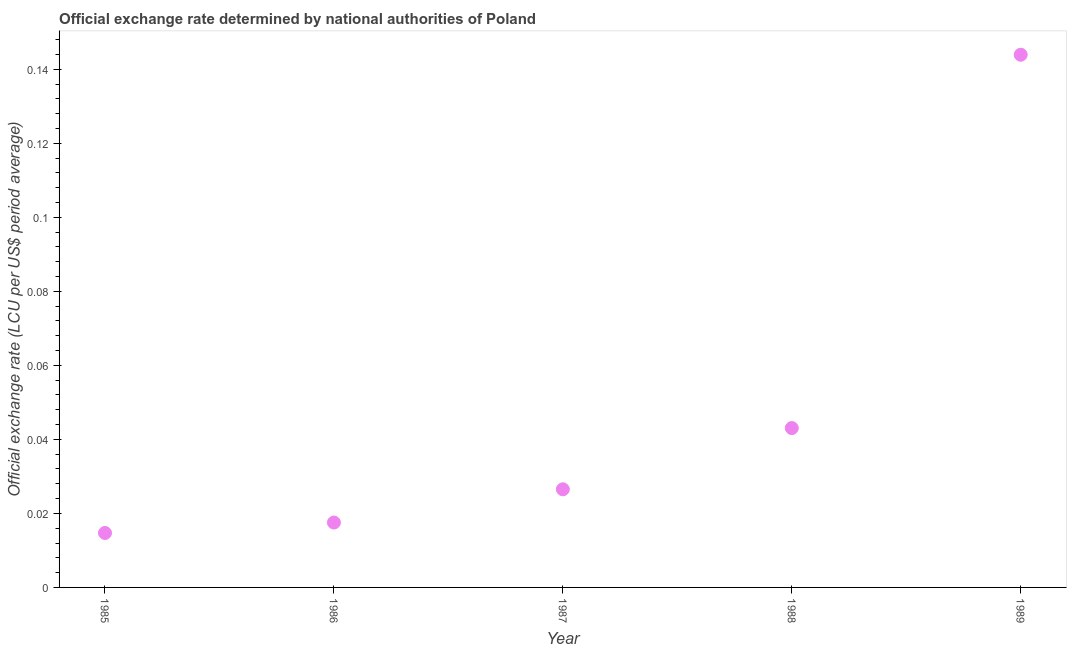What is the official exchange rate in 1985?
Ensure brevity in your answer.  0.01. Across all years, what is the maximum official exchange rate?
Provide a succinct answer. 0.14. Across all years, what is the minimum official exchange rate?
Offer a very short reply. 0.01. In which year was the official exchange rate minimum?
Your answer should be very brief. 1985. What is the sum of the official exchange rate?
Make the answer very short. 0.25. What is the difference between the official exchange rate in 1987 and 1988?
Your response must be concise. -0.02. What is the average official exchange rate per year?
Keep it short and to the point. 0.05. What is the median official exchange rate?
Your answer should be very brief. 0.03. In how many years, is the official exchange rate greater than 0.06 ?
Ensure brevity in your answer.  1. Do a majority of the years between 1986 and 1985 (inclusive) have official exchange rate greater than 0.056 ?
Offer a very short reply. No. What is the ratio of the official exchange rate in 1985 to that in 1986?
Your answer should be very brief. 0.84. Is the official exchange rate in 1987 less than that in 1989?
Make the answer very short. Yes. Is the difference between the official exchange rate in 1985 and 1987 greater than the difference between any two years?
Offer a very short reply. No. What is the difference between the highest and the second highest official exchange rate?
Give a very brief answer. 0.1. What is the difference between the highest and the lowest official exchange rate?
Your answer should be compact. 0.13. In how many years, is the official exchange rate greater than the average official exchange rate taken over all years?
Your response must be concise. 1. Does the official exchange rate monotonically increase over the years?
Ensure brevity in your answer.  Yes. How many years are there in the graph?
Keep it short and to the point. 5. What is the difference between two consecutive major ticks on the Y-axis?
Your response must be concise. 0.02. Does the graph contain grids?
Provide a short and direct response. No. What is the title of the graph?
Your answer should be very brief. Official exchange rate determined by national authorities of Poland. What is the label or title of the X-axis?
Your response must be concise. Year. What is the label or title of the Y-axis?
Offer a terse response. Official exchange rate (LCU per US$ period average). What is the Official exchange rate (LCU per US$ period average) in 1985?
Your answer should be compact. 0.01. What is the Official exchange rate (LCU per US$ period average) in 1986?
Offer a very short reply. 0.02. What is the Official exchange rate (LCU per US$ period average) in 1987?
Provide a succinct answer. 0.03. What is the Official exchange rate (LCU per US$ period average) in 1988?
Keep it short and to the point. 0.04. What is the Official exchange rate (LCU per US$ period average) in 1989?
Offer a very short reply. 0.14. What is the difference between the Official exchange rate (LCU per US$ period average) in 1985 and 1986?
Offer a very short reply. -0. What is the difference between the Official exchange rate (LCU per US$ period average) in 1985 and 1987?
Make the answer very short. -0.01. What is the difference between the Official exchange rate (LCU per US$ period average) in 1985 and 1988?
Ensure brevity in your answer.  -0.03. What is the difference between the Official exchange rate (LCU per US$ period average) in 1985 and 1989?
Provide a succinct answer. -0.13. What is the difference between the Official exchange rate (LCU per US$ period average) in 1986 and 1987?
Your answer should be compact. -0.01. What is the difference between the Official exchange rate (LCU per US$ period average) in 1986 and 1988?
Give a very brief answer. -0.03. What is the difference between the Official exchange rate (LCU per US$ period average) in 1986 and 1989?
Provide a succinct answer. -0.13. What is the difference between the Official exchange rate (LCU per US$ period average) in 1987 and 1988?
Offer a terse response. -0.02. What is the difference between the Official exchange rate (LCU per US$ period average) in 1987 and 1989?
Your answer should be compact. -0.12. What is the difference between the Official exchange rate (LCU per US$ period average) in 1988 and 1989?
Provide a short and direct response. -0.1. What is the ratio of the Official exchange rate (LCU per US$ period average) in 1985 to that in 1986?
Keep it short and to the point. 0.84. What is the ratio of the Official exchange rate (LCU per US$ period average) in 1985 to that in 1987?
Keep it short and to the point. 0.56. What is the ratio of the Official exchange rate (LCU per US$ period average) in 1985 to that in 1988?
Your answer should be compact. 0.34. What is the ratio of the Official exchange rate (LCU per US$ period average) in 1985 to that in 1989?
Offer a terse response. 0.1. What is the ratio of the Official exchange rate (LCU per US$ period average) in 1986 to that in 1987?
Your answer should be very brief. 0.66. What is the ratio of the Official exchange rate (LCU per US$ period average) in 1986 to that in 1988?
Offer a very short reply. 0.41. What is the ratio of the Official exchange rate (LCU per US$ period average) in 1986 to that in 1989?
Your answer should be compact. 0.12. What is the ratio of the Official exchange rate (LCU per US$ period average) in 1987 to that in 1988?
Offer a very short reply. 0.62. What is the ratio of the Official exchange rate (LCU per US$ period average) in 1987 to that in 1989?
Offer a terse response. 0.18. What is the ratio of the Official exchange rate (LCU per US$ period average) in 1988 to that in 1989?
Offer a very short reply. 0.3. 